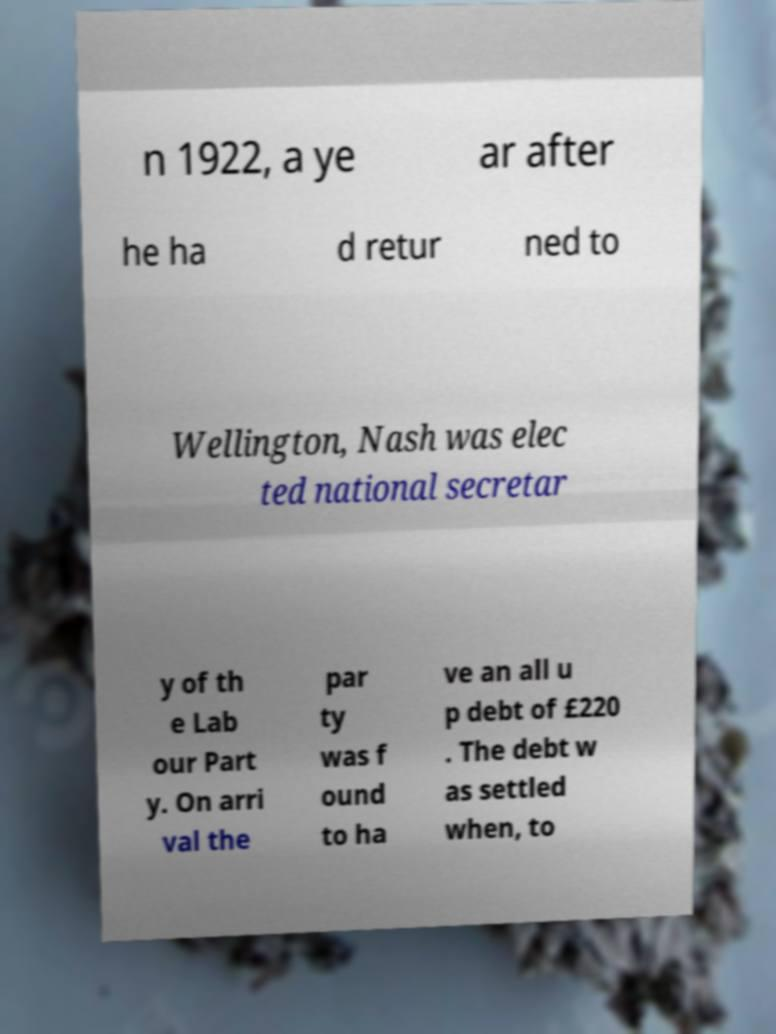Could you assist in decoding the text presented in this image and type it out clearly? n 1922, a ye ar after he ha d retur ned to Wellington, Nash was elec ted national secretar y of th e Lab our Part y. On arri val the par ty was f ound to ha ve an all u p debt of £220 . The debt w as settled when, to 